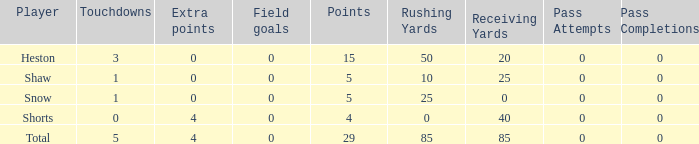What is the sum of all the touchdowns when the player had more than 0 extra points and less than 0 field goals? None. 